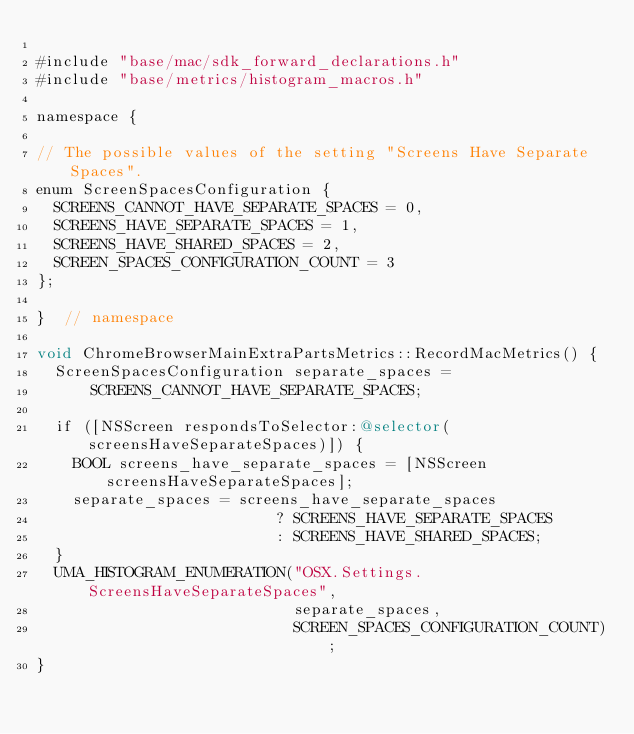Convert code to text. <code><loc_0><loc_0><loc_500><loc_500><_ObjectiveC_>
#include "base/mac/sdk_forward_declarations.h"
#include "base/metrics/histogram_macros.h"

namespace {

// The possible values of the setting "Screens Have Separate Spaces".
enum ScreenSpacesConfiguration {
  SCREENS_CANNOT_HAVE_SEPARATE_SPACES = 0,
  SCREENS_HAVE_SEPARATE_SPACES = 1,
  SCREENS_HAVE_SHARED_SPACES = 2,
  SCREEN_SPACES_CONFIGURATION_COUNT = 3
};

}  // namespace

void ChromeBrowserMainExtraPartsMetrics::RecordMacMetrics() {
  ScreenSpacesConfiguration separate_spaces =
      SCREENS_CANNOT_HAVE_SEPARATE_SPACES;

  if ([NSScreen respondsToSelector:@selector(screensHaveSeparateSpaces)]) {
    BOOL screens_have_separate_spaces = [NSScreen screensHaveSeparateSpaces];
    separate_spaces = screens_have_separate_spaces
                          ? SCREENS_HAVE_SEPARATE_SPACES
                          : SCREENS_HAVE_SHARED_SPACES;
  }
  UMA_HISTOGRAM_ENUMERATION("OSX.Settings.ScreensHaveSeparateSpaces",
                            separate_spaces,
                            SCREEN_SPACES_CONFIGURATION_COUNT);
}
</code> 